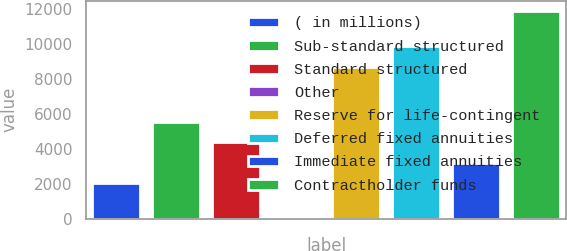Convert chart to OTSL. <chart><loc_0><loc_0><loc_500><loc_500><bar_chart><fcel>( in millions)<fcel>Sub-standard structured<fcel>Standard structured<fcel>Other<fcel>Reserve for life-contingent<fcel>Deferred fixed annuities<fcel>Immediate fixed annuities<fcel>Contractholder funds<nl><fcel>2016<fcel>5560.5<fcel>4379<fcel>100<fcel>8721<fcel>9902.5<fcel>3197.5<fcel>11915<nl></chart> 